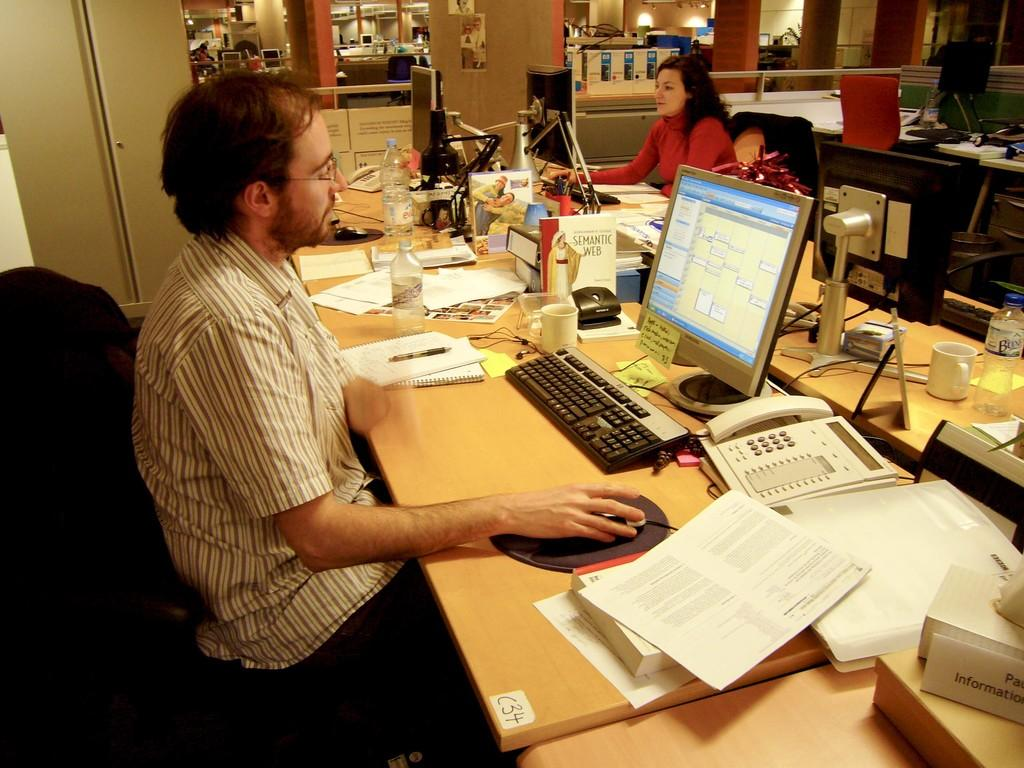Provide a one-sentence caption for the provided image. A man sitting at a desk on a computer with a sticker placed on the edge of the desk that has C34 written on it. 